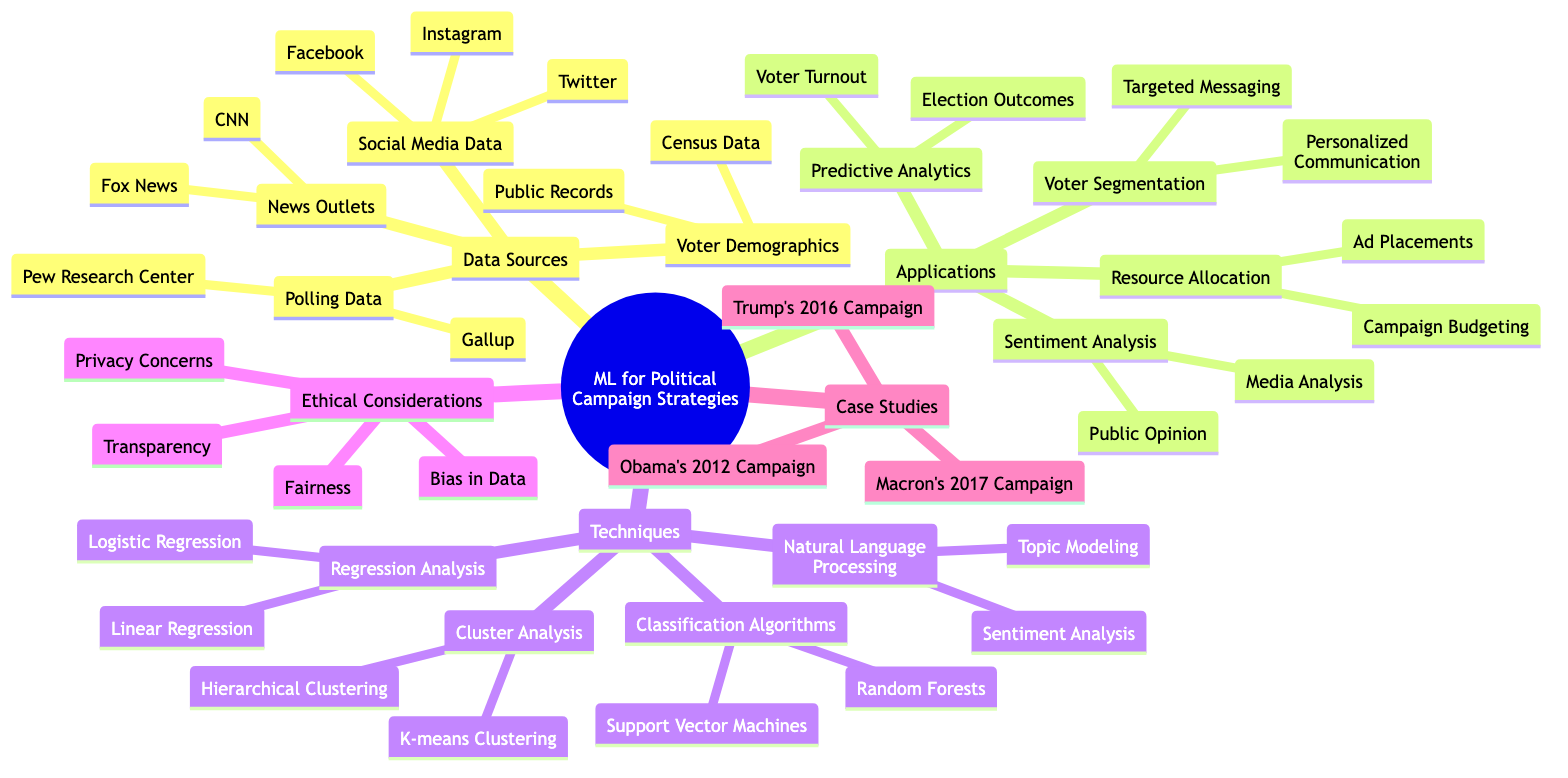What types of data sources are utilized? The diagram shows that there are four types of data sources, which include Social Media Data, Polling Data, Voter Demographics, and News Outlets.
Answer: Four Which platforms are listed under Social Media Data? According to the diagram, Social Media Data includes Twitter, Facebook, and Instagram. These are all the platforms listed under that category.
Answer: Twitter, Facebook, Instagram How many applications are identified for using machine learning in political campaigns? The diagram indicates there are four distinct applications: Voter Segmentation, Sentiment Analysis, Predictive Analytics, and Resource Allocation.
Answer: Four What is one ethical consideration mentioned in the diagram? From the ethical considerations portion of the diagram, one of the issues listed is Bias in Data. This is one of the key concerns outlined.
Answer: Bias in Data Which technique is categorized under Natural Language Processing? The diagram includes Sentiment Analysis and Topic Modeling under the Natural Language Processing category. Both are defined as techniques used in machine learning for political campaigns.
Answer: Sentiment Analysis, Topic Modeling What case study is associated with Obama's 2012 campaign? The diagram explicitly lists Obama's 2012 Campaign as one of the case studies demonstrating the application of machine learning in political strategies.
Answer: Obama's 2012 Campaign How many classification algorithms are mentioned? The diagram shows two classification algorithms: Support Vector Machines and Random Forests, confirming that there are two techniques listed under this section.
Answer: Two What relationship exists between Voter Segmentation and Targeted Messaging? The diagram indicates that Voter Segmentation leads to Targeted Messaging, suggesting a direct application of this strategy in political campaigns.
Answer: Leads to What do Predictive Analytics assess according to the diagram? The diagram clearly states that Predictive Analytics includes assessing Election Outcomes and Voter Turnout, indicating that these are the focus areas.
Answer: Election Outcomes, Voter Turnout 